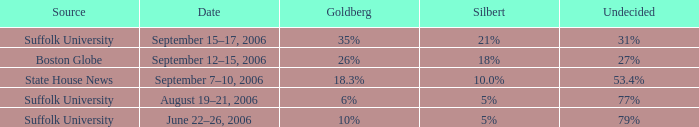What is the undecided percentage of the poll from Suffolk University with Murray at 11%? 77%. Could you parse the entire table? {'header': ['Source', 'Date', 'Goldberg', 'Silbert', 'Undecided'], 'rows': [['Suffolk University', 'September 15–17, 2006', '35%', '21%', '31%'], ['Boston Globe', 'September 12–15, 2006', '26%', '18%', '27%'], ['State House News', 'September 7–10, 2006', '18.3%', '10.0%', '53.4%'], ['Suffolk University', 'August 19–21, 2006', '6%', '5%', '77%'], ['Suffolk University', 'June 22–26, 2006', '10%', '5%', '79%']]} 